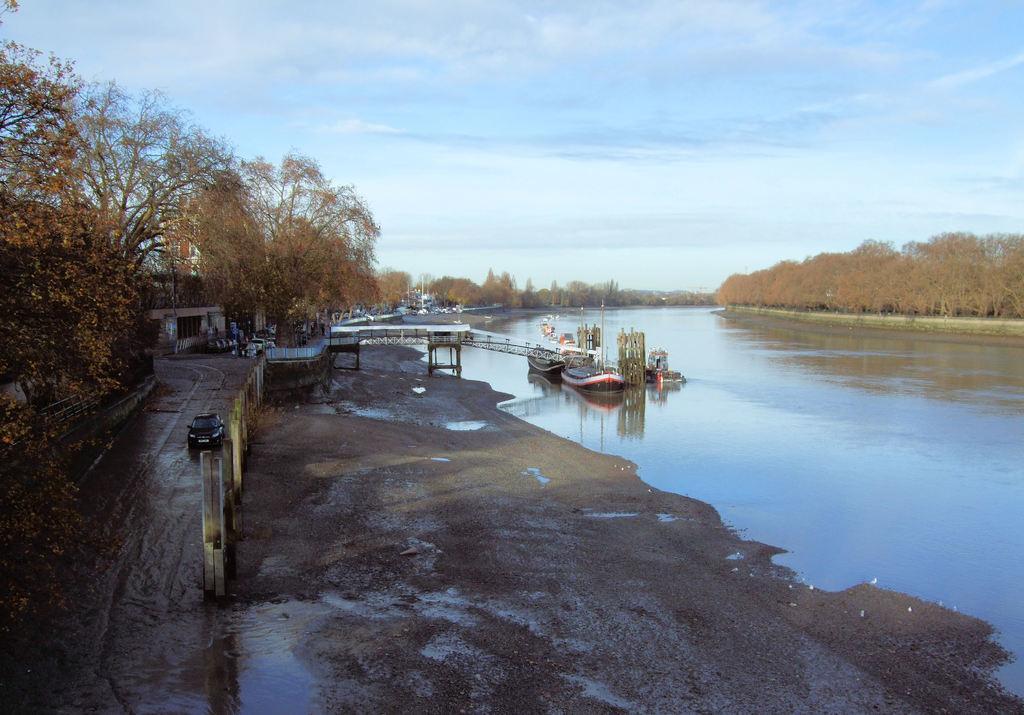Can you describe this image briefly? Vehicle is on the road. Here we can see boats, water, trees and building. Sky is cloudy. 